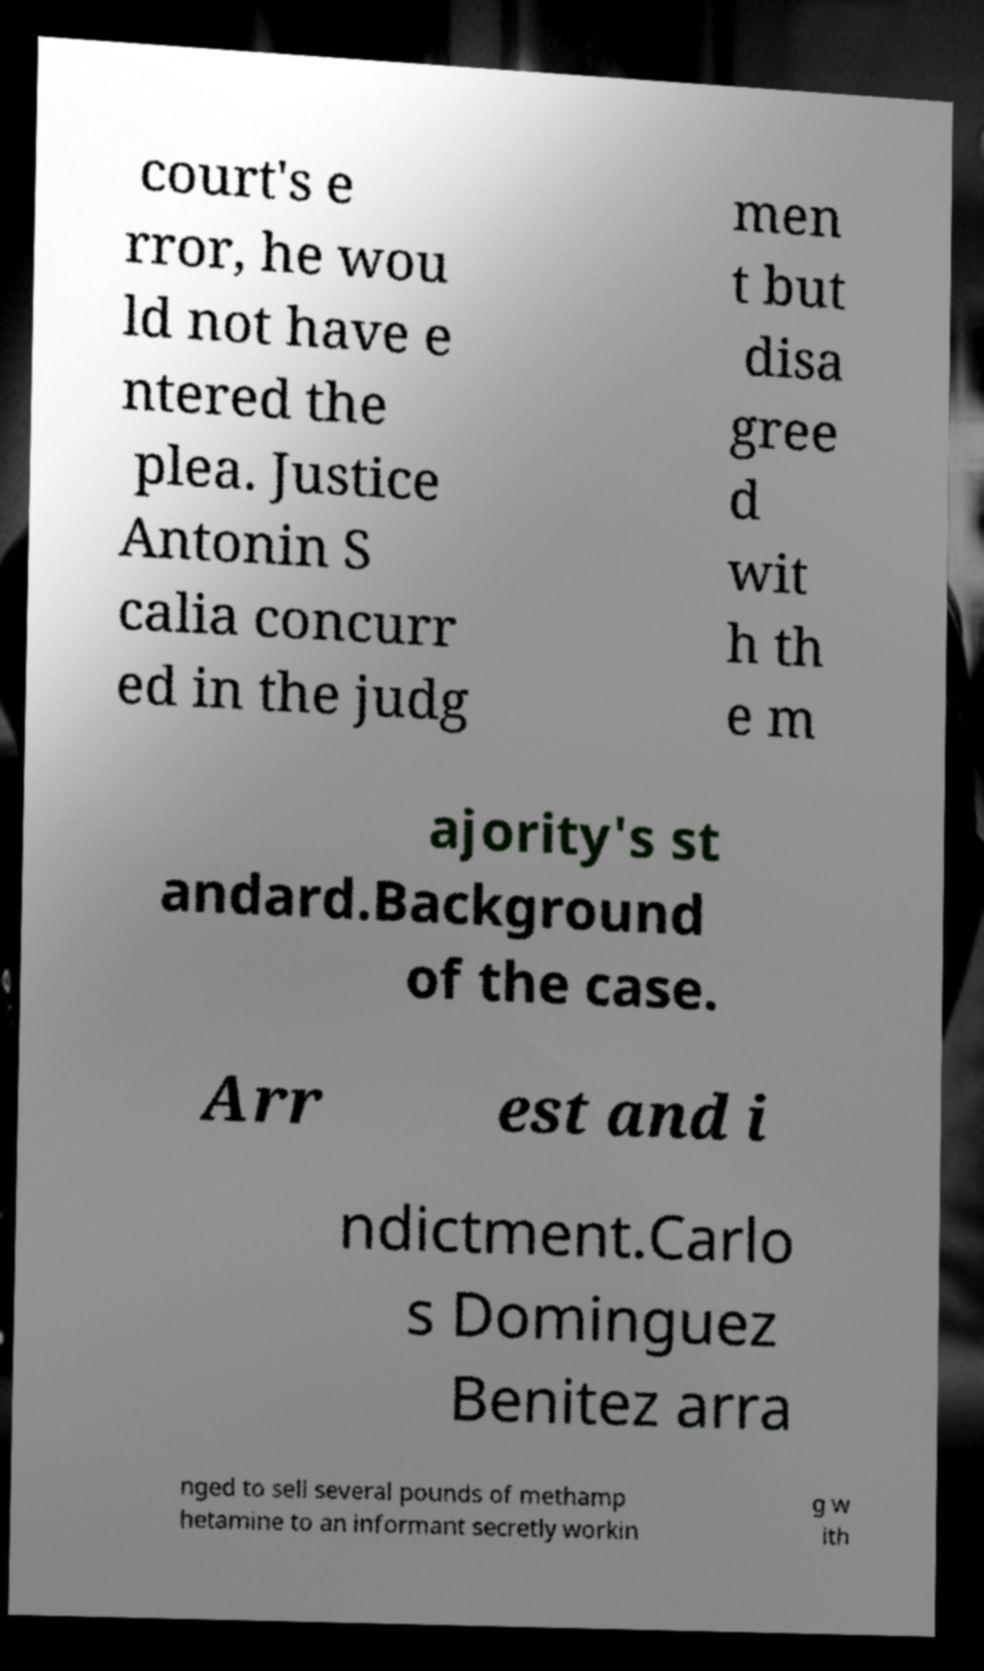For documentation purposes, I need the text within this image transcribed. Could you provide that? court's e rror, he wou ld not have e ntered the plea. Justice Antonin S calia concurr ed in the judg men t but disa gree d wit h th e m ajority's st andard.Background of the case. Arr est and i ndictment.Carlo s Dominguez Benitez arra nged to sell several pounds of methamp hetamine to an informant secretly workin g w ith 